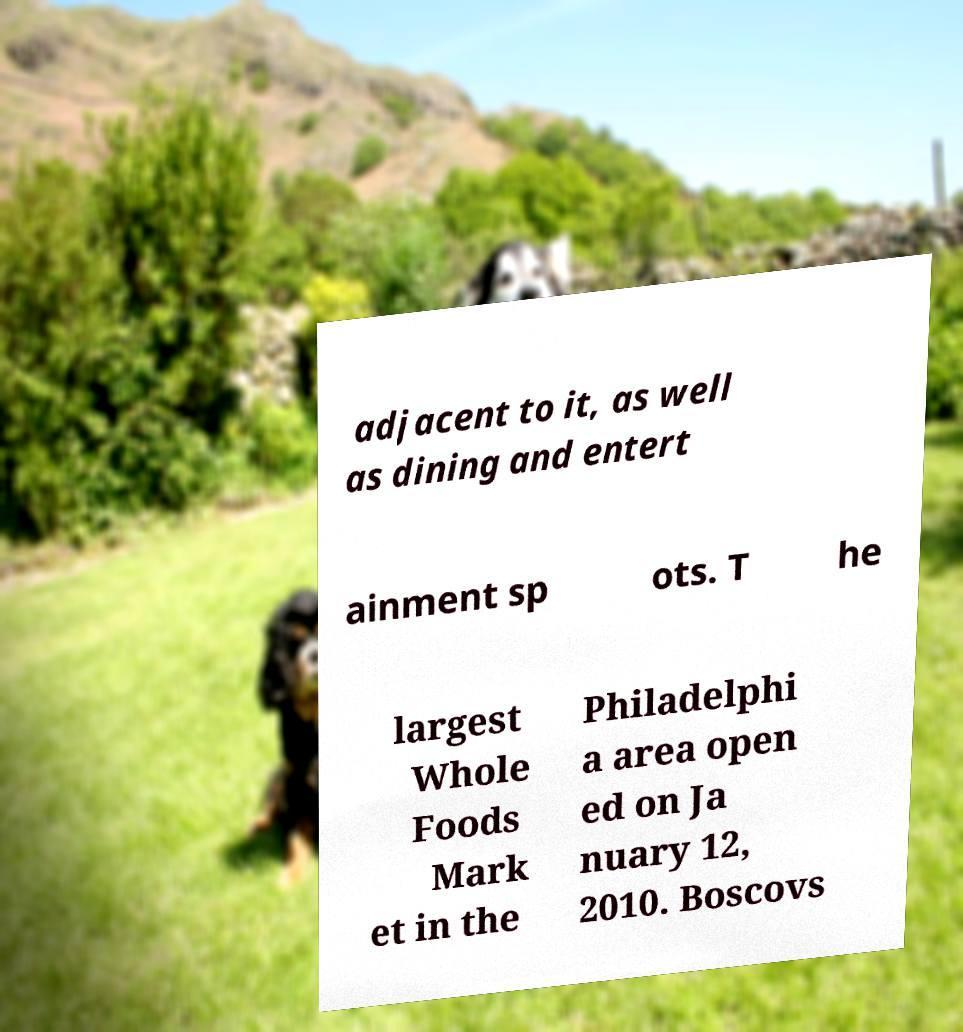I need the written content from this picture converted into text. Can you do that? adjacent to it, as well as dining and entert ainment sp ots. T he largest Whole Foods Mark et in the Philadelphi a area open ed on Ja nuary 12, 2010. Boscovs 